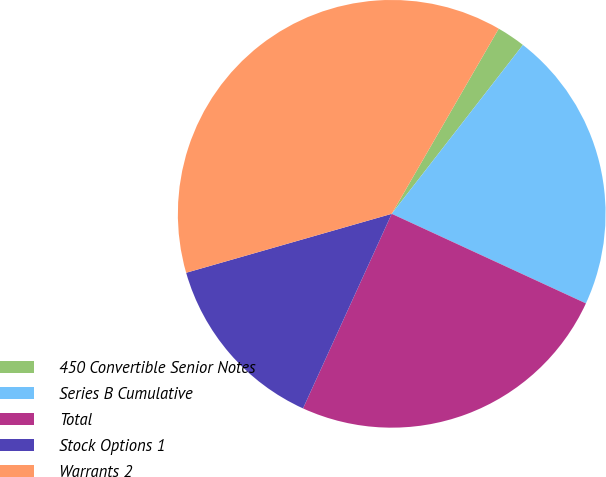Convert chart. <chart><loc_0><loc_0><loc_500><loc_500><pie_chart><fcel>450 Convertible Senior Notes<fcel>Series B Cumulative<fcel>Total<fcel>Stock Options 1<fcel>Warrants 2<nl><fcel>2.17%<fcel>21.37%<fcel>24.93%<fcel>13.75%<fcel>37.79%<nl></chart> 